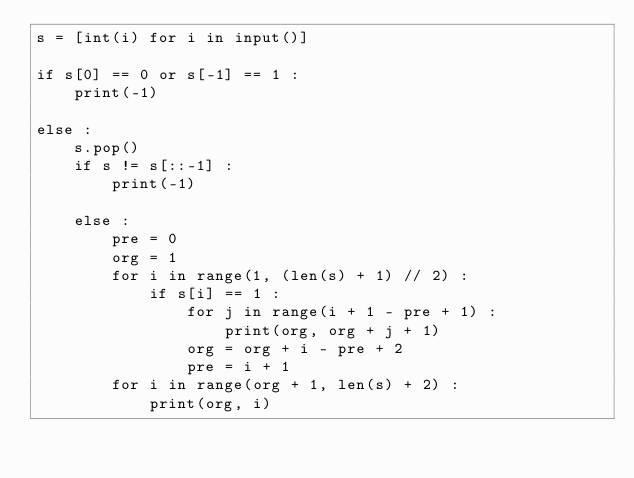Convert code to text. <code><loc_0><loc_0><loc_500><loc_500><_Python_>s = [int(i) for i in input()]

if s[0] == 0 or s[-1] == 1 :
    print(-1)
    
else :
    s.pop()
    if s != s[::-1] :
        print(-1)
        
    else :
        pre = 0
        org = 1
        for i in range(1, (len(s) + 1) // 2) :
            if s[i] == 1 :
                for j in range(i + 1 - pre + 1) :
                    print(org, org + j + 1)
                org = org + i - pre + 2
                pre = i + 1
        for i in range(org + 1, len(s) + 2) :
            print(org, i)</code> 